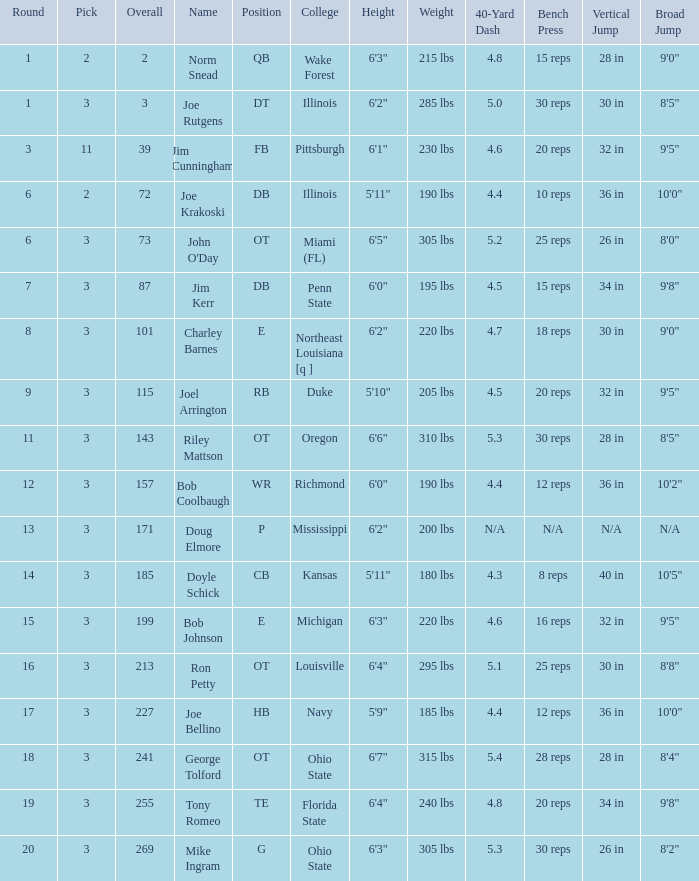How many overalls have charley barnes as the name, with a pick less than 3? None. 